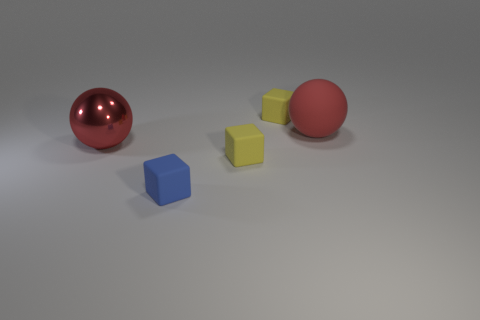Is the number of matte balls in front of the large red metal ball the same as the number of red spheres that are behind the large matte ball?
Offer a terse response. Yes. What is the material of the large sphere left of the big red matte sphere?
Provide a short and direct response. Metal. Are there any other things that have the same size as the blue block?
Ensure brevity in your answer.  Yes. Are there fewer brown rubber balls than small blue blocks?
Offer a very short reply. Yes. How many tiny things are there?
Provide a succinct answer. 3. There is a ball that is to the left of the thing that is behind the big rubber sphere that is behind the red metal sphere; what is it made of?
Your response must be concise. Metal. What number of tiny yellow cubes are behind the yellow matte block that is in front of the red rubber ball?
Offer a terse response. 1. There is another big thing that is the same shape as the red metallic thing; what color is it?
Your response must be concise. Red. What number of blocks are large red matte things or yellow rubber things?
Provide a short and direct response. 2. What is the size of the ball behind the big red sphere that is left of the large object that is behind the large red metallic object?
Your answer should be very brief. Large. 